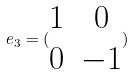<formula> <loc_0><loc_0><loc_500><loc_500>e _ { 3 } = ( \begin{matrix} 1 & 0 \\ 0 & - 1 \end{matrix} )</formula> 